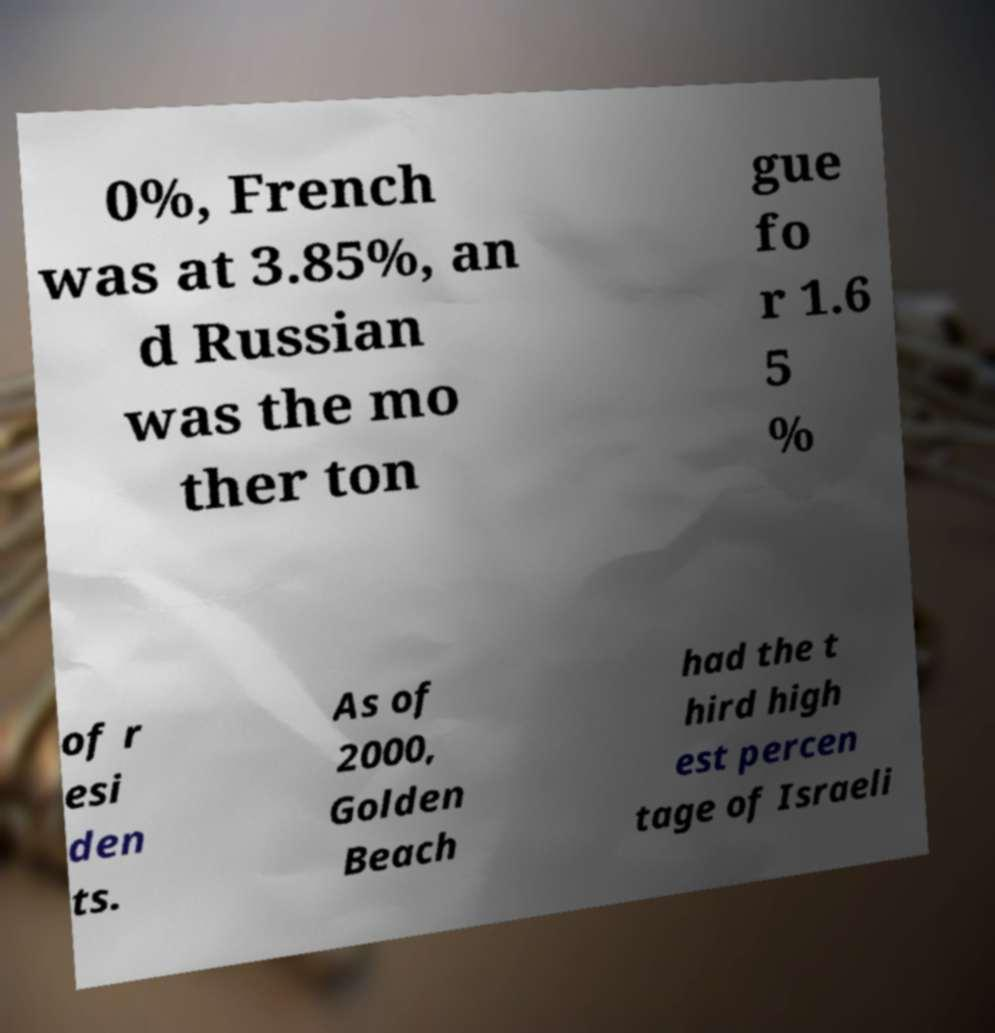Could you extract and type out the text from this image? 0%, French was at 3.85%, an d Russian was the mo ther ton gue fo r 1.6 5 % of r esi den ts. As of 2000, Golden Beach had the t hird high est percen tage of Israeli 